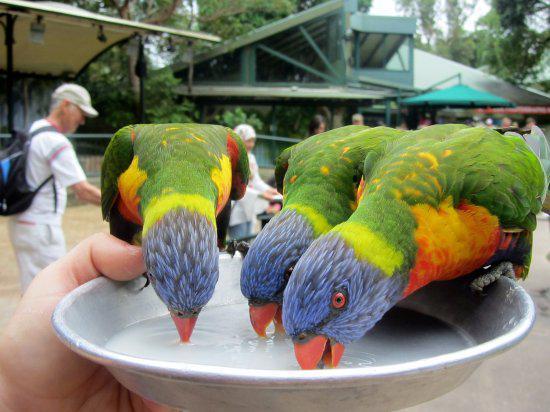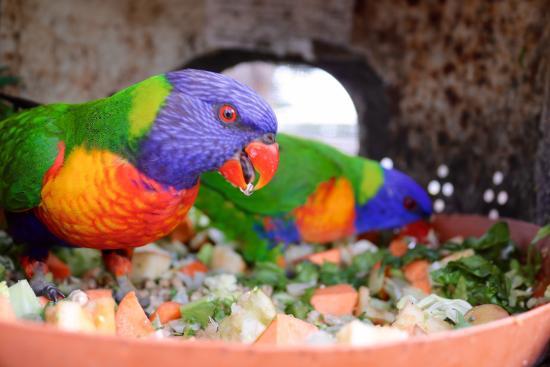The first image is the image on the left, the second image is the image on the right. Evaluate the accuracy of this statement regarding the images: "Left image shows a hand holding a round pan from which multi-colored birds drink.". Is it true? Answer yes or no. Yes. The first image is the image on the left, the second image is the image on the right. Evaluate the accuracy of this statement regarding the images: "There are lorikeets drinking from a silver, handheld bowl in the left image.". Is it true? Answer yes or no. Yes. 